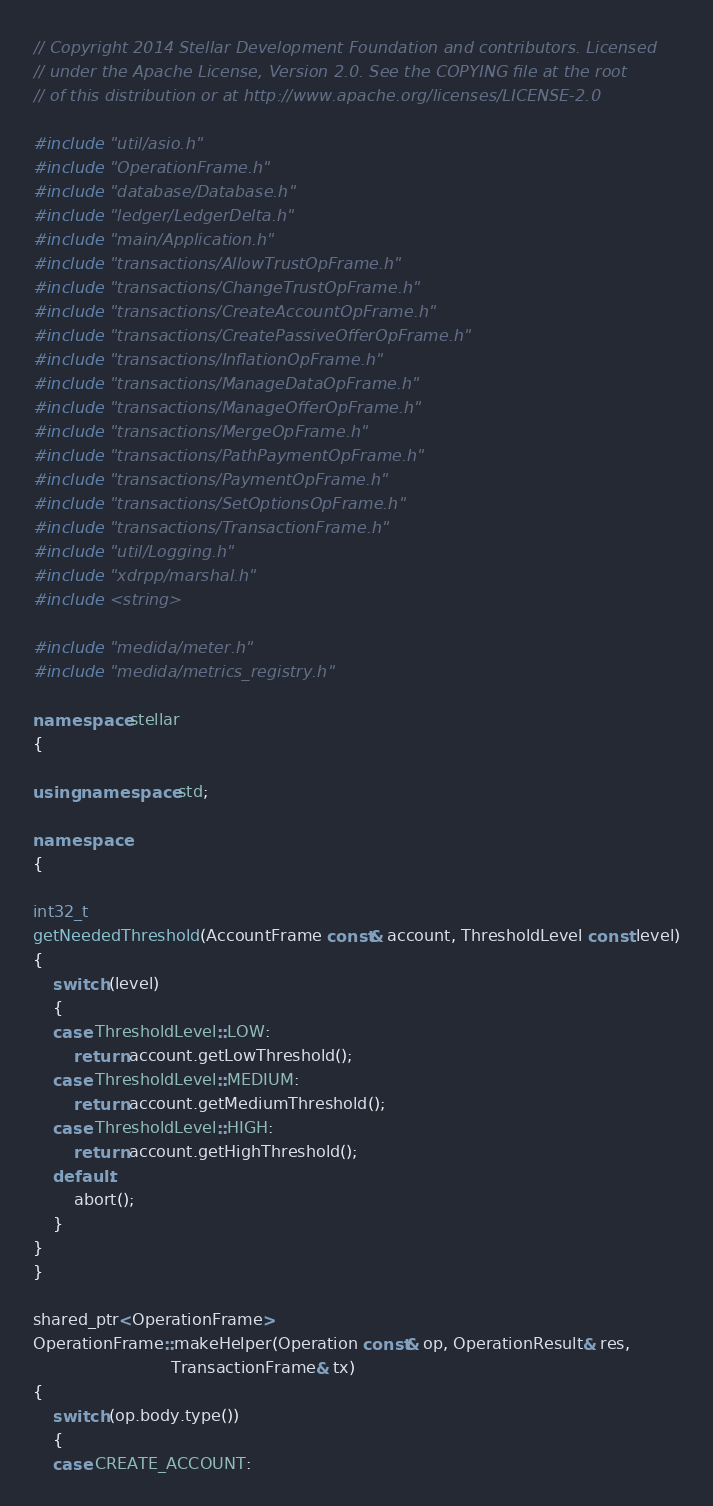Convert code to text. <code><loc_0><loc_0><loc_500><loc_500><_C++_>// Copyright 2014 Stellar Development Foundation and contributors. Licensed
// under the Apache License, Version 2.0. See the COPYING file at the root
// of this distribution or at http://www.apache.org/licenses/LICENSE-2.0

#include "util/asio.h"
#include "OperationFrame.h"
#include "database/Database.h"
#include "ledger/LedgerDelta.h"
#include "main/Application.h"
#include "transactions/AllowTrustOpFrame.h"
#include "transactions/ChangeTrustOpFrame.h"
#include "transactions/CreateAccountOpFrame.h"
#include "transactions/CreatePassiveOfferOpFrame.h"
#include "transactions/InflationOpFrame.h"
#include "transactions/ManageDataOpFrame.h"
#include "transactions/ManageOfferOpFrame.h"
#include "transactions/MergeOpFrame.h"
#include "transactions/PathPaymentOpFrame.h"
#include "transactions/PaymentOpFrame.h"
#include "transactions/SetOptionsOpFrame.h"
#include "transactions/TransactionFrame.h"
#include "util/Logging.h"
#include "xdrpp/marshal.h"
#include <string>

#include "medida/meter.h"
#include "medida/metrics_registry.h"

namespace stellar
{

using namespace std;

namespace
{

int32_t
getNeededThreshold(AccountFrame const& account, ThresholdLevel const level)
{
    switch (level)
    {
    case ThresholdLevel::LOW:
        return account.getLowThreshold();
    case ThresholdLevel::MEDIUM:
        return account.getMediumThreshold();
    case ThresholdLevel::HIGH:
        return account.getHighThreshold();
    default:
        abort();
    }
}
}

shared_ptr<OperationFrame>
OperationFrame::makeHelper(Operation const& op, OperationResult& res,
                           TransactionFrame& tx)
{
    switch (op.body.type())
    {
    case CREATE_ACCOUNT:</code> 